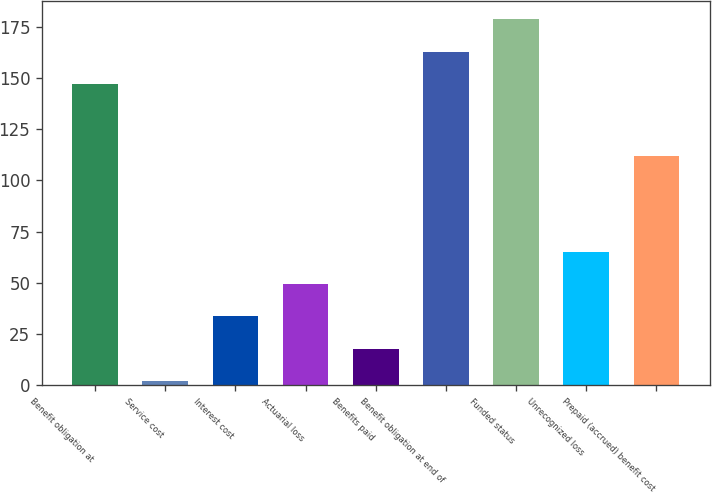Convert chart to OTSL. <chart><loc_0><loc_0><loc_500><loc_500><bar_chart><fcel>Benefit obligation at<fcel>Service cost<fcel>Interest cost<fcel>Actuarial loss<fcel>Benefits paid<fcel>Benefit obligation at end of<fcel>Funded status<fcel>Unrecognized loss<fcel>Prepaid (accrued) benefit cost<nl><fcel>147<fcel>2<fcel>33.56<fcel>49.34<fcel>17.78<fcel>162.78<fcel>178.56<fcel>65.12<fcel>112<nl></chart> 